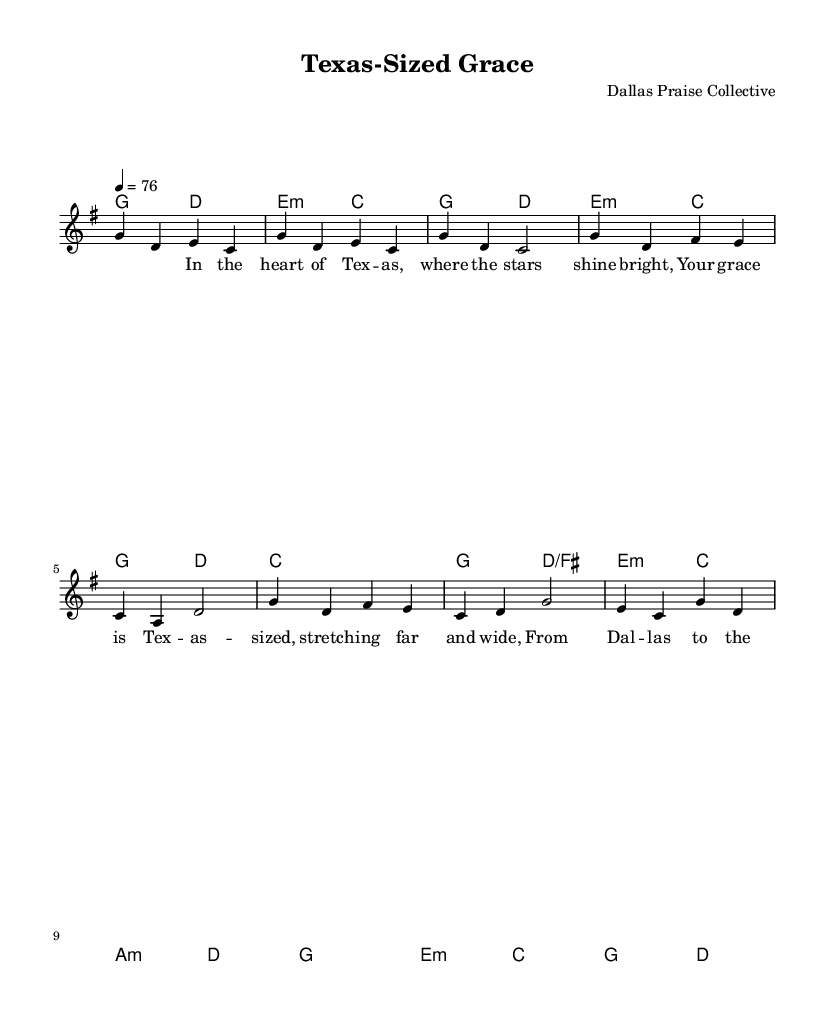What is the key signature of this music? The key signature is indicated at the beginning of the staff. In this case, there is one sharp, signifying that the key is G major.
Answer: G major What is the time signature of this music? The time signature is shown at the beginning of the staff, represented as 4/4, which indicates four beats per measure.
Answer: 4/4 What is the tempo marking of this piece? The tempo marking is stated as "4 = 76," meaning quarter note equals seventy-six beats per minute.
Answer: 76 How many measures are in the chorus section? The chorus includes multiple measures, and by counting from the music sheet, there are four distinct measures presented in that section.
Answer: 4 What is the predominant chord used in the introduction? The introduction primarily features the G major chord at the start, as stated in the harmonies.
Answer: G major In what part of the song does the phrase "Your grace is Texas-sized" appear? This phrase comes up during the chorus, as indicated in the lyrics under the staff in the provided music.
Answer: Chorus What is the last note of the melody? The last note of the melody can be found in the bridge section and is identified as 'd', which is a note that rounds off the bridge line.
Answer: d 